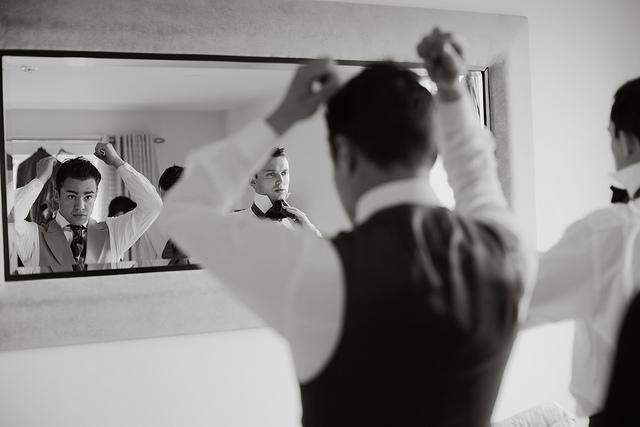How many people can be seen?
Give a very brief answer. 3. 